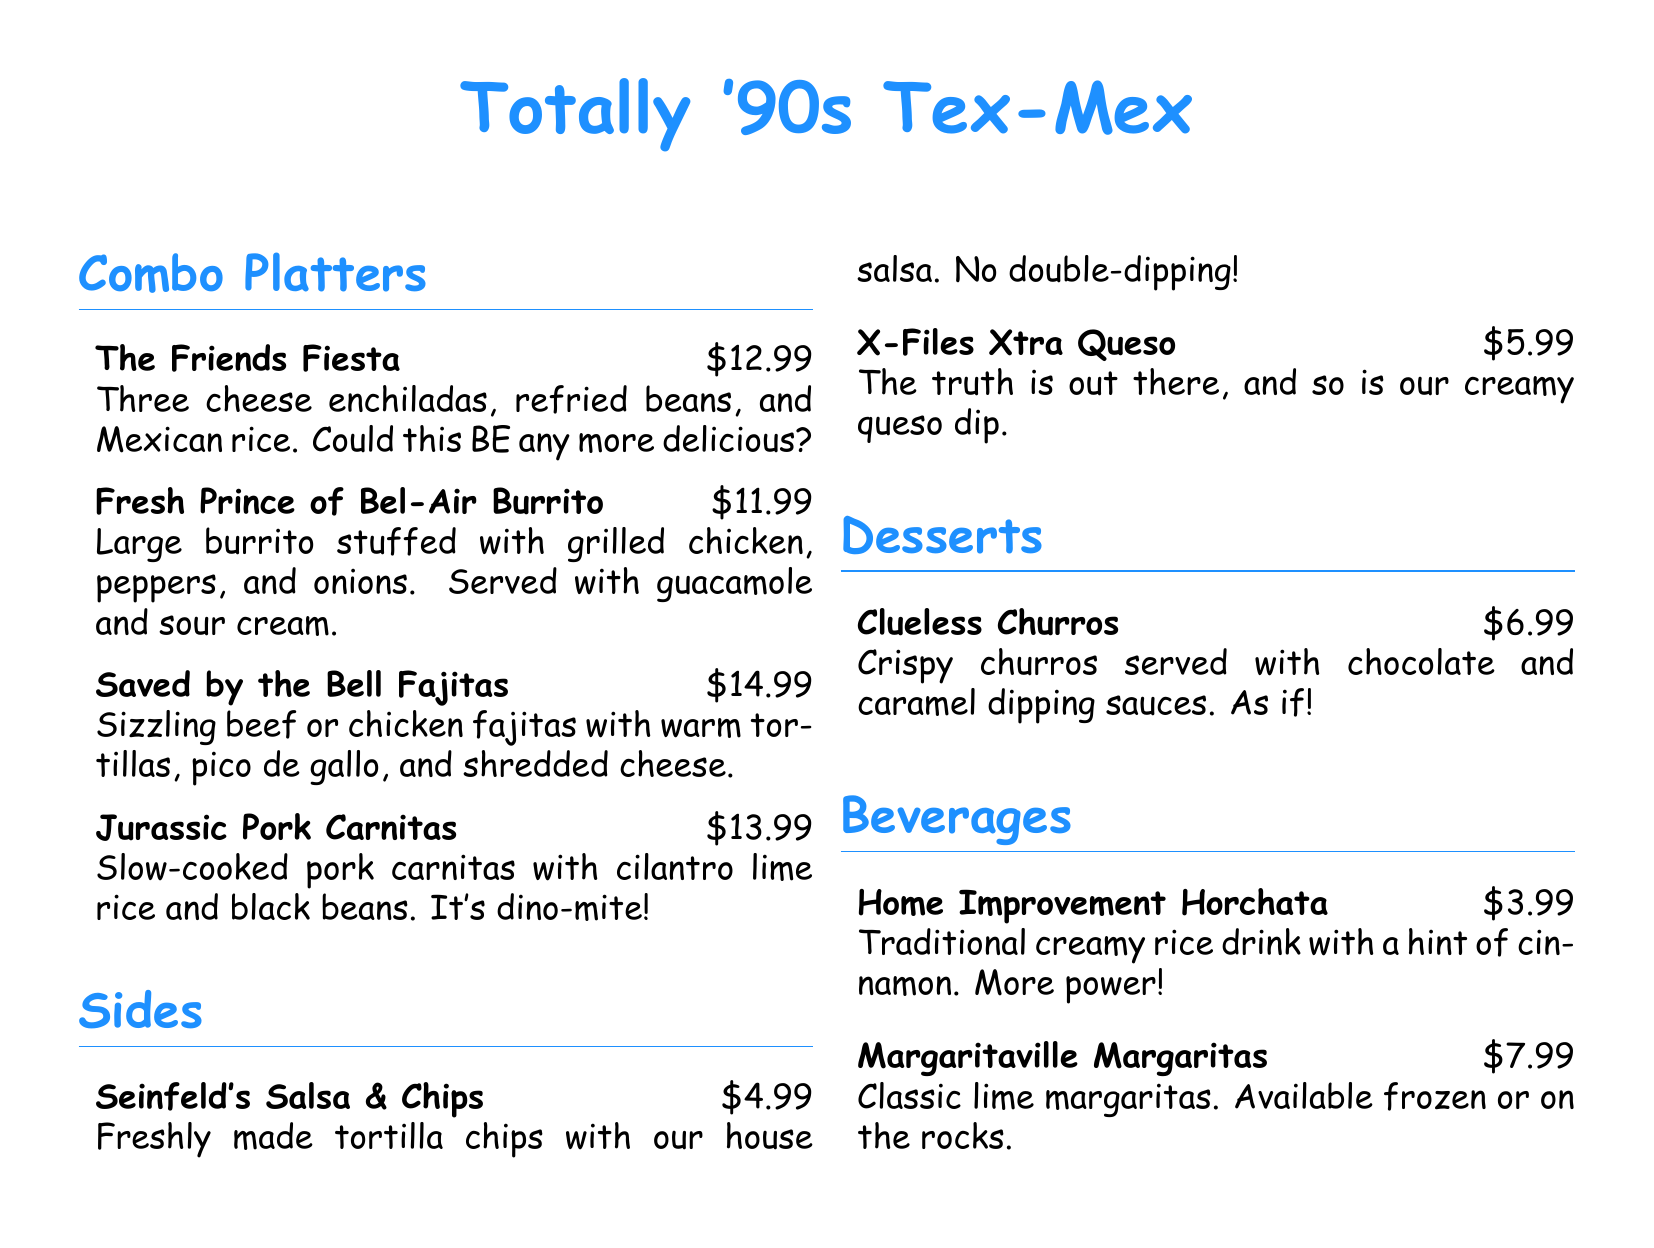What is the price of The Friends Fiesta? The price of The Friends Fiesta is $12.99 as stated in the document.
Answer: $12.99 What dessert comes with dipping sauces? The dessert that comes with dipping sauces is Clueless Churros, mentioned in the desserts section.
Answer: Clueless Churros What type of drink is Home Improvement Horchata? Home Improvement Horchata is described as a traditional creamy rice drink with a hint of cinnamon.
Answer: Creamy rice drink How many sides are listed on the menu? There are two sides listed on the menu: Seinfeld's Salsa & Chips and X-Files Xtra Queso.
Answer: Two Which combo platter includes carnitas? The combo platter that includes carnitas is Jurassic Pork Carnitas as per the text in the document.
Answer: Jurassic Pork Carnitas What do the Fresh Prince of Bel-Air Burrito come with? The Fresh Prince of Bel-Air Burrito comes with guacamole and sour cream as stated in the description.
Answer: Guacamole and sour cream What is the price of the X-Files Xtra Queso? The price of the X-Files Xtra Queso is $5.99 according to the menu.
Answer: $5.99 Which combo has a fun Jurassic theme? The combo with a fun Jurassic theme is Jurassic Pork Carnitas, noted in its description.
Answer: Jurassic Pork Carnitas 